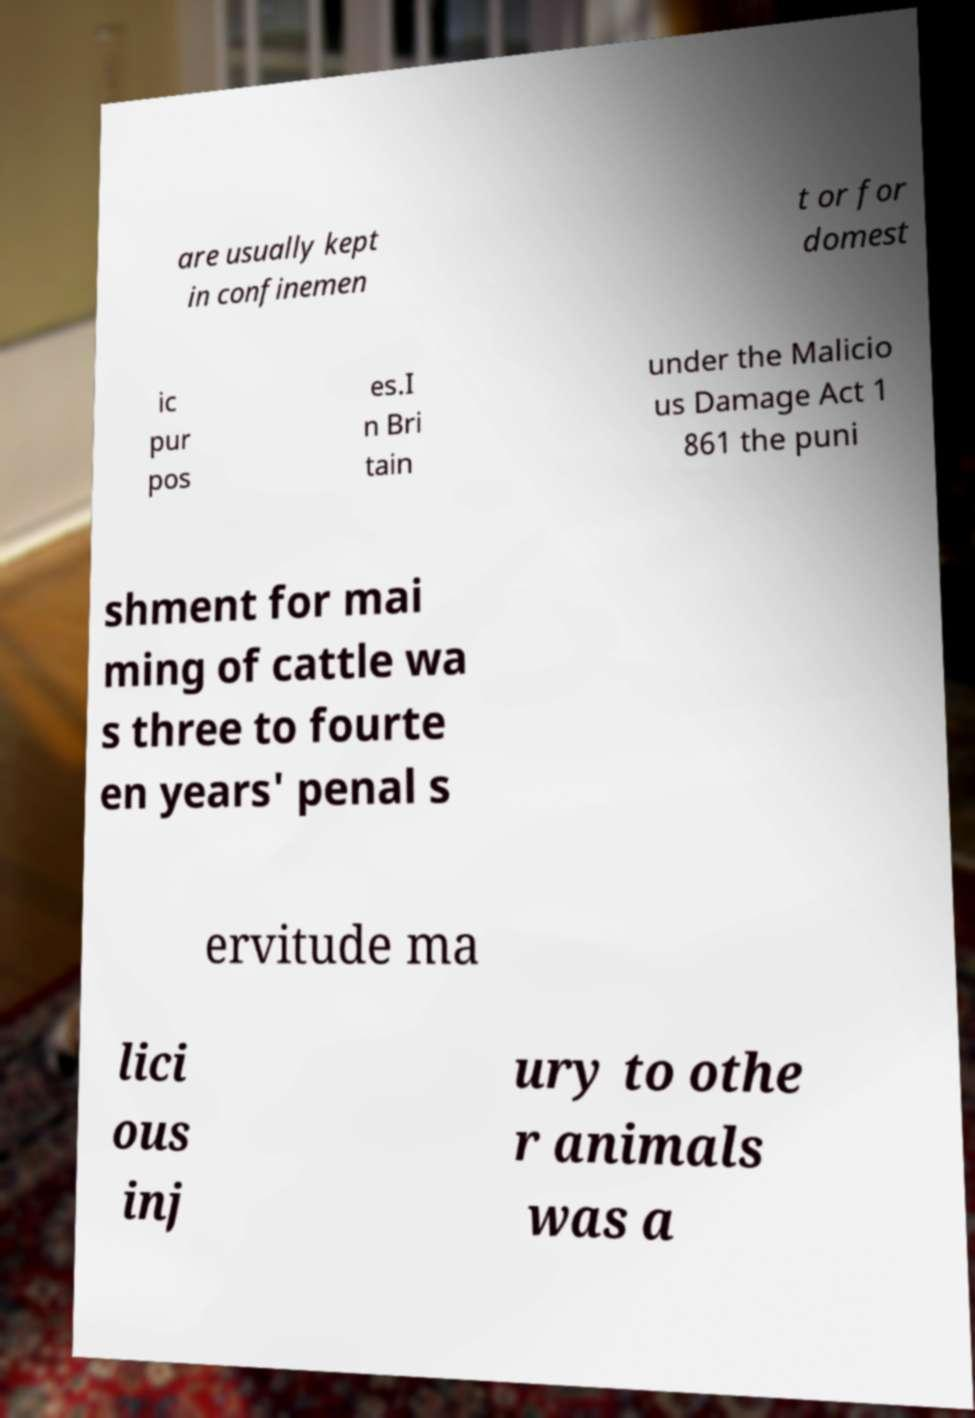Please identify and transcribe the text found in this image. are usually kept in confinemen t or for domest ic pur pos es.I n Bri tain under the Malicio us Damage Act 1 861 the puni shment for mai ming of cattle wa s three to fourte en years' penal s ervitude ma lici ous inj ury to othe r animals was a 